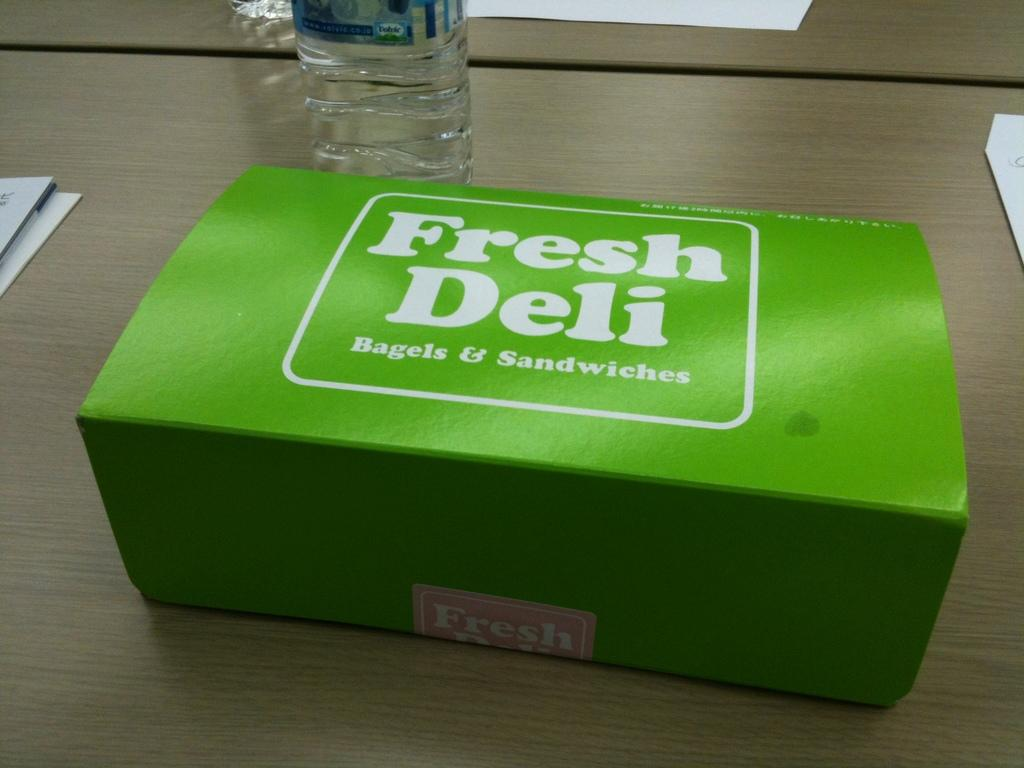<image>
Describe the image concisely. A green box from Fresh Deli sits on a table next to a bottle of water. 